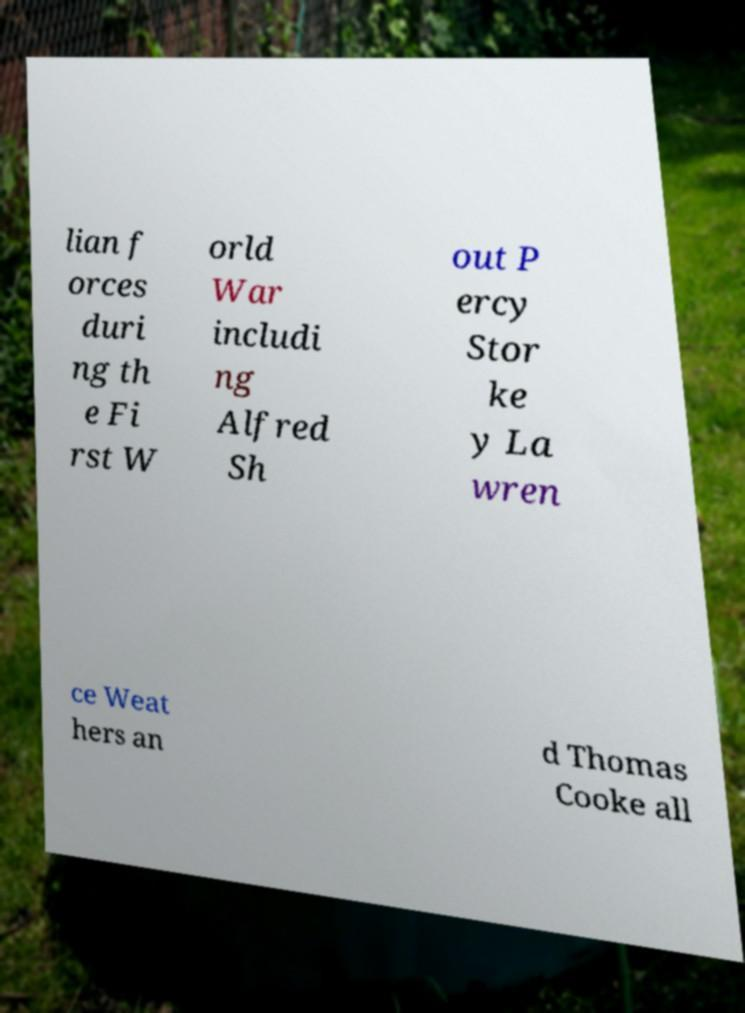Please identify and transcribe the text found in this image. lian f orces duri ng th e Fi rst W orld War includi ng Alfred Sh out P ercy Stor ke y La wren ce Weat hers an d Thomas Cooke all 